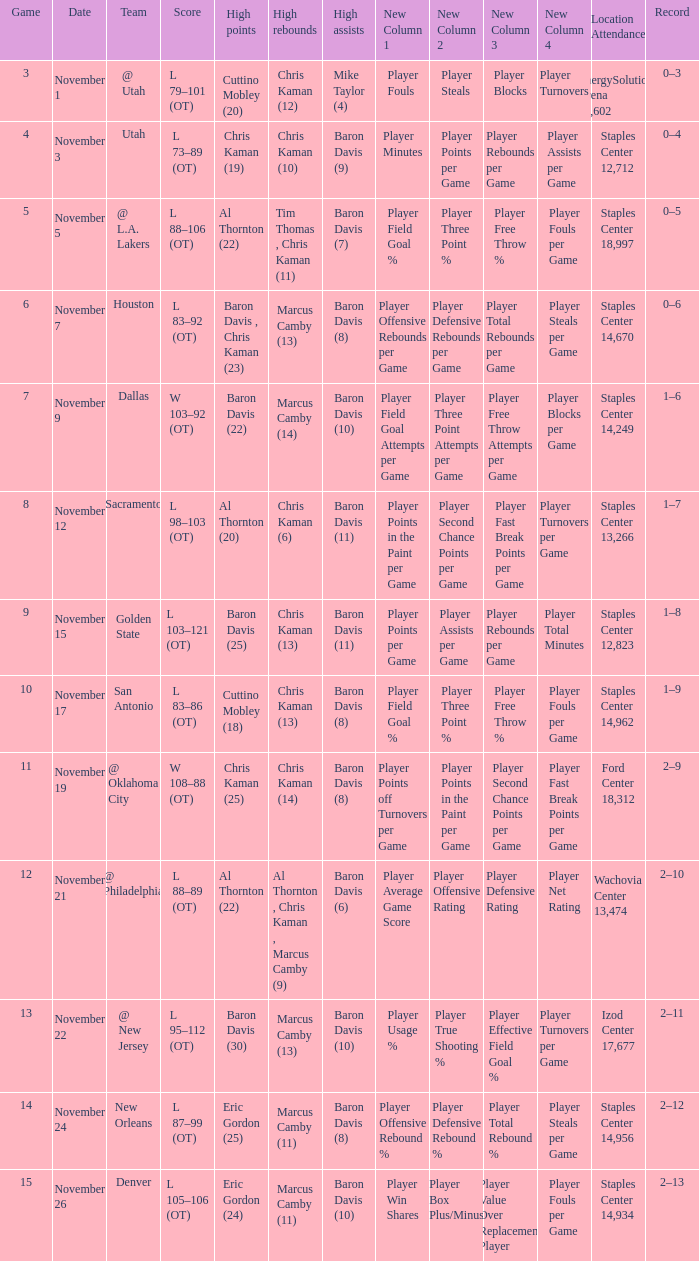Name the high points for the date of november 24 Eric Gordon (25). 